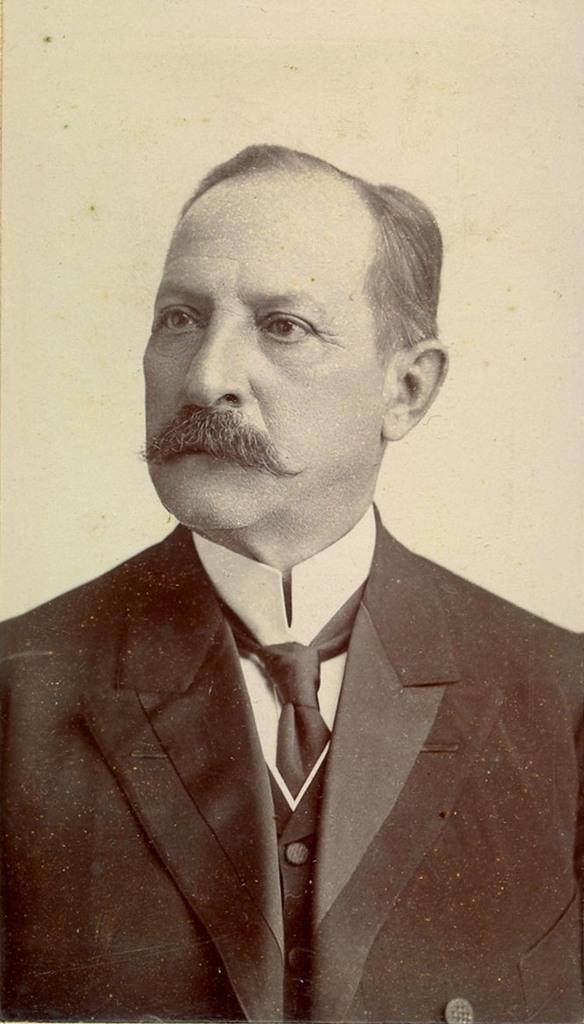Describe this image in one or two sentences. In this image there is one person who is wearing a suit, and in the background there is a wall. 